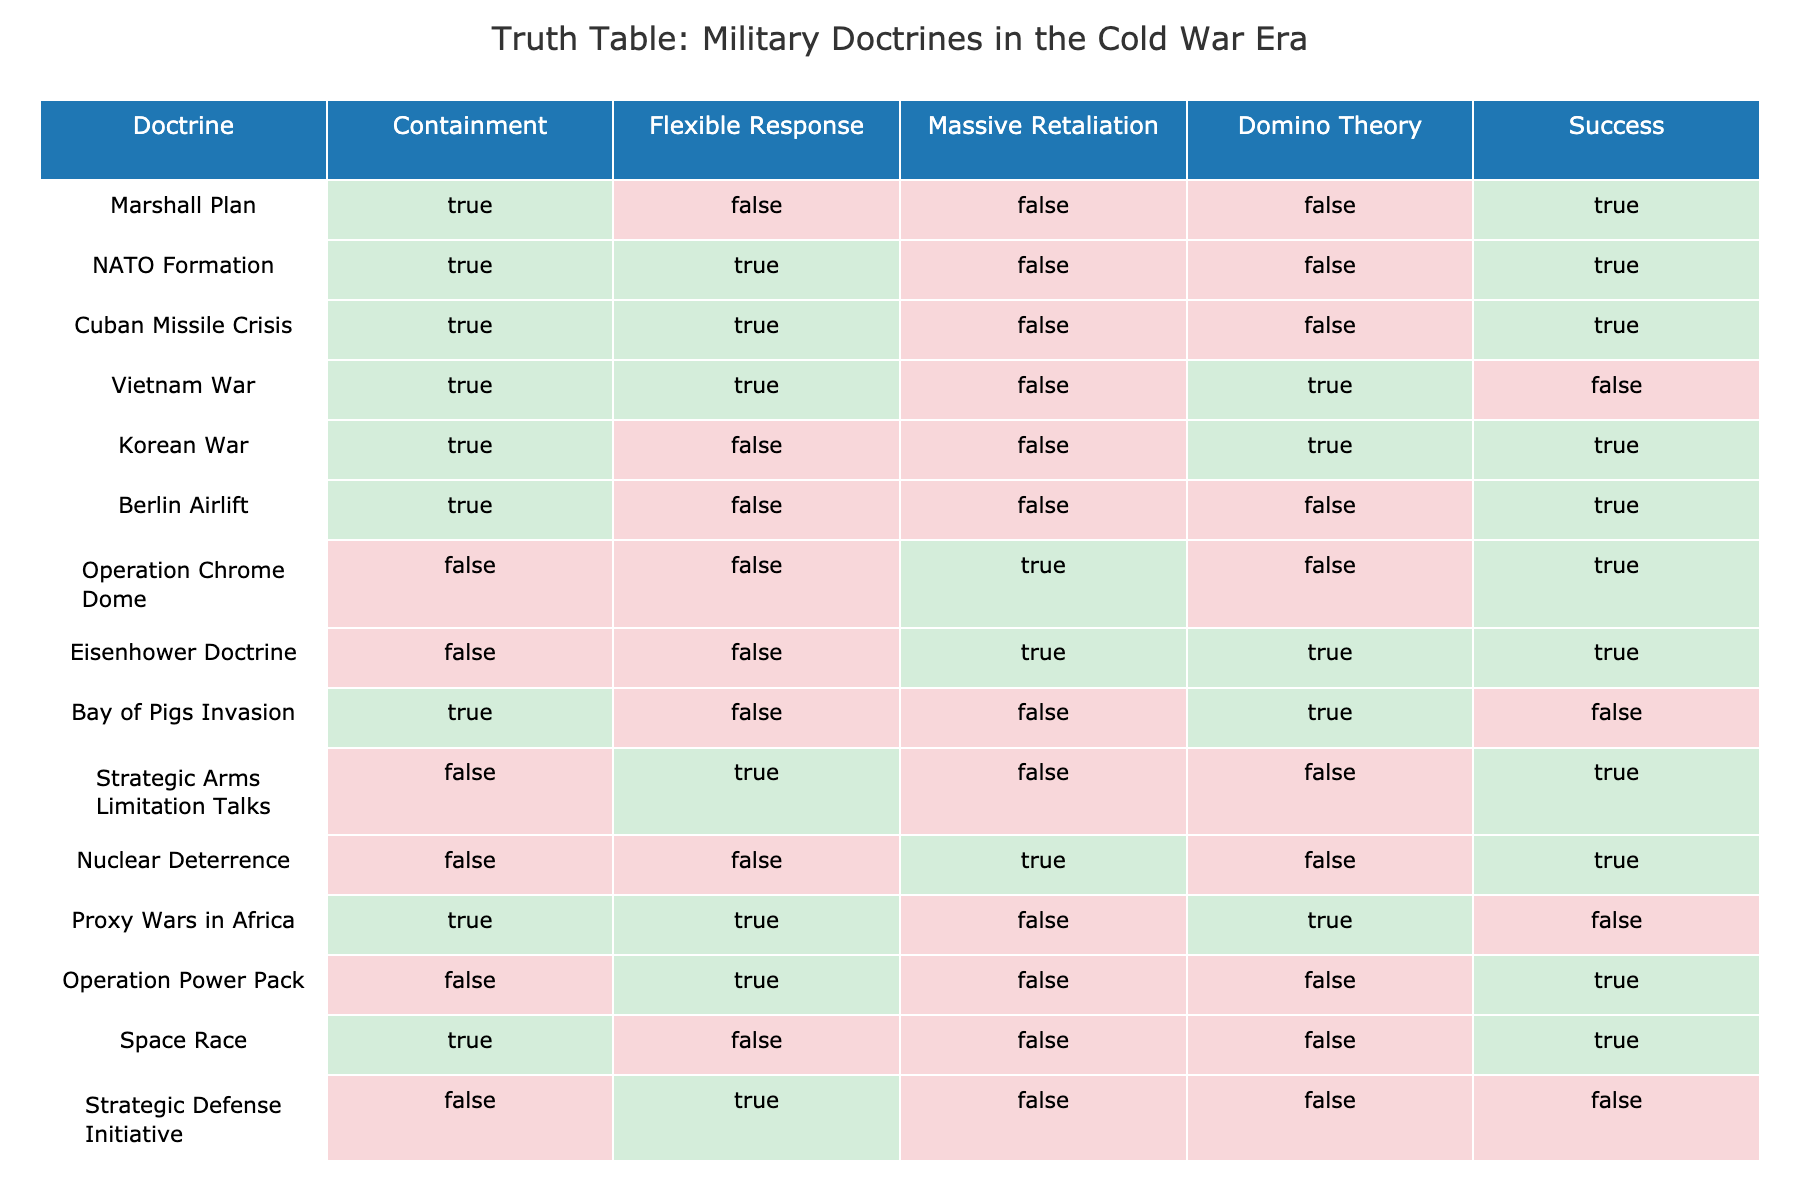What is the success rate of the "Cuban Missile Crisis"? The "Cuban Missile Crisis" is listed under the "Success" column as TRUE. This indicates that it was successful according to the table.
Answer: TRUE Which doctrines were involved in the "Vietnam War"? The "Vietnam War" has TRUE marked in the "Containment" and "Flexible Response" columns, while "Massive Retaliation" is FALSE, and "Domino Theory" is TRUE. This indicates that both Containment and Flexible Response were applied, while Domino Theory was also considered relevant.
Answer: Containment and Flexible Response How many doctrines achieved success while involving the "Massive Retaliation"? To find this, we look at the "Massive Retaliation" column for TRUE values. The "Operation Chrome Dome," "Eisenhower Doctrine," and "Nuclear Deterrence" are successful with Massive Retaliation involved, giving a total of three.
Answer: 3 Did the "Berlin Airlift" get a FALSE in the "Domino Theory" column? By checking the "Berlin Airlift" row, we find that it indeed has FALSE in the "Domino Theory" column indicating that this doctrine did not apply to the Berlin Airlift.
Answer: TRUE Which military doctrine had success while utilizing "Flexible Response" but did not succeed in the "Vietnam War"? Looking at the table, we identify that "Strategic Arms Limitation Talks" and "Operation Power Pack" had TRUE for "Flexible Response" and also achieved success, despite "Vietnam War" being unsuccessful.
Answer: Strategic Arms Limitation Talks, Operation Power Pack What is the total number of successful doctrines that utilized "Containment"? Count the rows where "Containment" is TRUE and the "Success" column is also TRUE. The successful doctrines are "Marshall Plan," "NATO Formation," "Cuban Missile Crisis," "Korean War," and "Berlin Airlift," resulting in a total of five successful doctrines using Containment.
Answer: 5 Name the doctrine that achieved success with "Domino Theory" but did not use "Containment". The only doctrine that has TRUE under "Domino Theory" and FALSE under "Containment" is the "Vietnam War."
Answer: Vietnam War How many doctrines had FALSE for both "Flexible Response" and "Massive Retaliation" but had success? The doctrines that meet this condition are "Berlin Airlift" and "Operation Power Pack," resulting in a total of two such doctrines.
Answer: 2 Which doctrine had TRUE for all its strategies but still did not succeed? Examining the table, we find that the "Vietnam War" is marked TRUE for "Containment," "Flexible Response," and "Domino Theory," but has FALSE in the success column, thus it did not succeed.
Answer: Vietnam War 